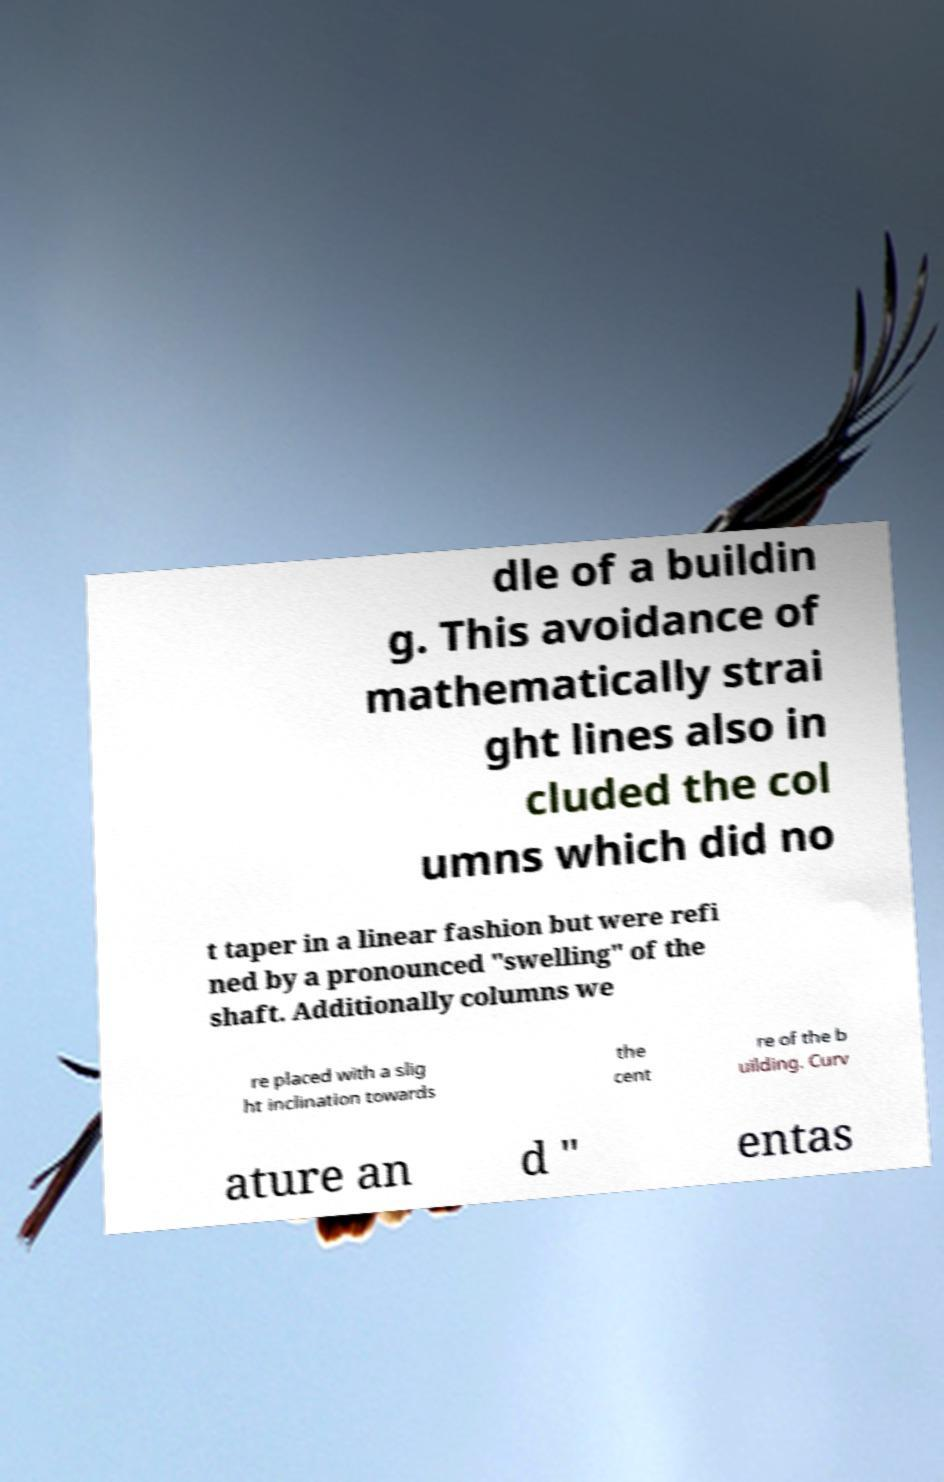Please read and relay the text visible in this image. What does it say? dle of a buildin g. This avoidance of mathematically strai ght lines also in cluded the col umns which did no t taper in a linear fashion but were refi ned by a pronounced "swelling" of the shaft. Additionally columns we re placed with a slig ht inclination towards the cent re of the b uilding. Curv ature an d " entas 